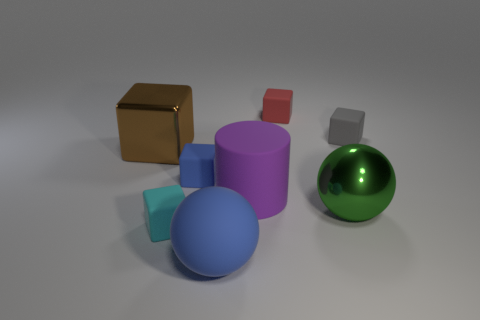Are there any tiny cubes that have the same color as the large matte sphere?
Offer a terse response. Yes. How many rubber things have the same color as the large rubber ball?
Your answer should be compact. 1. There is a cylinder that is the same material as the gray thing; what color is it?
Make the answer very short. Purple. Are there any red blocks that have the same size as the cyan rubber object?
Make the answer very short. Yes. How many things are either rubber objects that are on the left side of the gray matte object or large shiny things in front of the cylinder?
Provide a succinct answer. 6. What is the shape of the blue matte thing that is the same size as the gray matte cube?
Ensure brevity in your answer.  Cube. Is there a cyan matte object that has the same shape as the big brown object?
Provide a succinct answer. Yes. Are there fewer large purple metallic balls than small red rubber cubes?
Offer a very short reply. Yes. There is a metal object that is right of the brown shiny object; is it the same size as the ball that is in front of the big green shiny ball?
Offer a terse response. Yes. What number of objects are big blue matte things or small rubber things?
Provide a succinct answer. 5. 